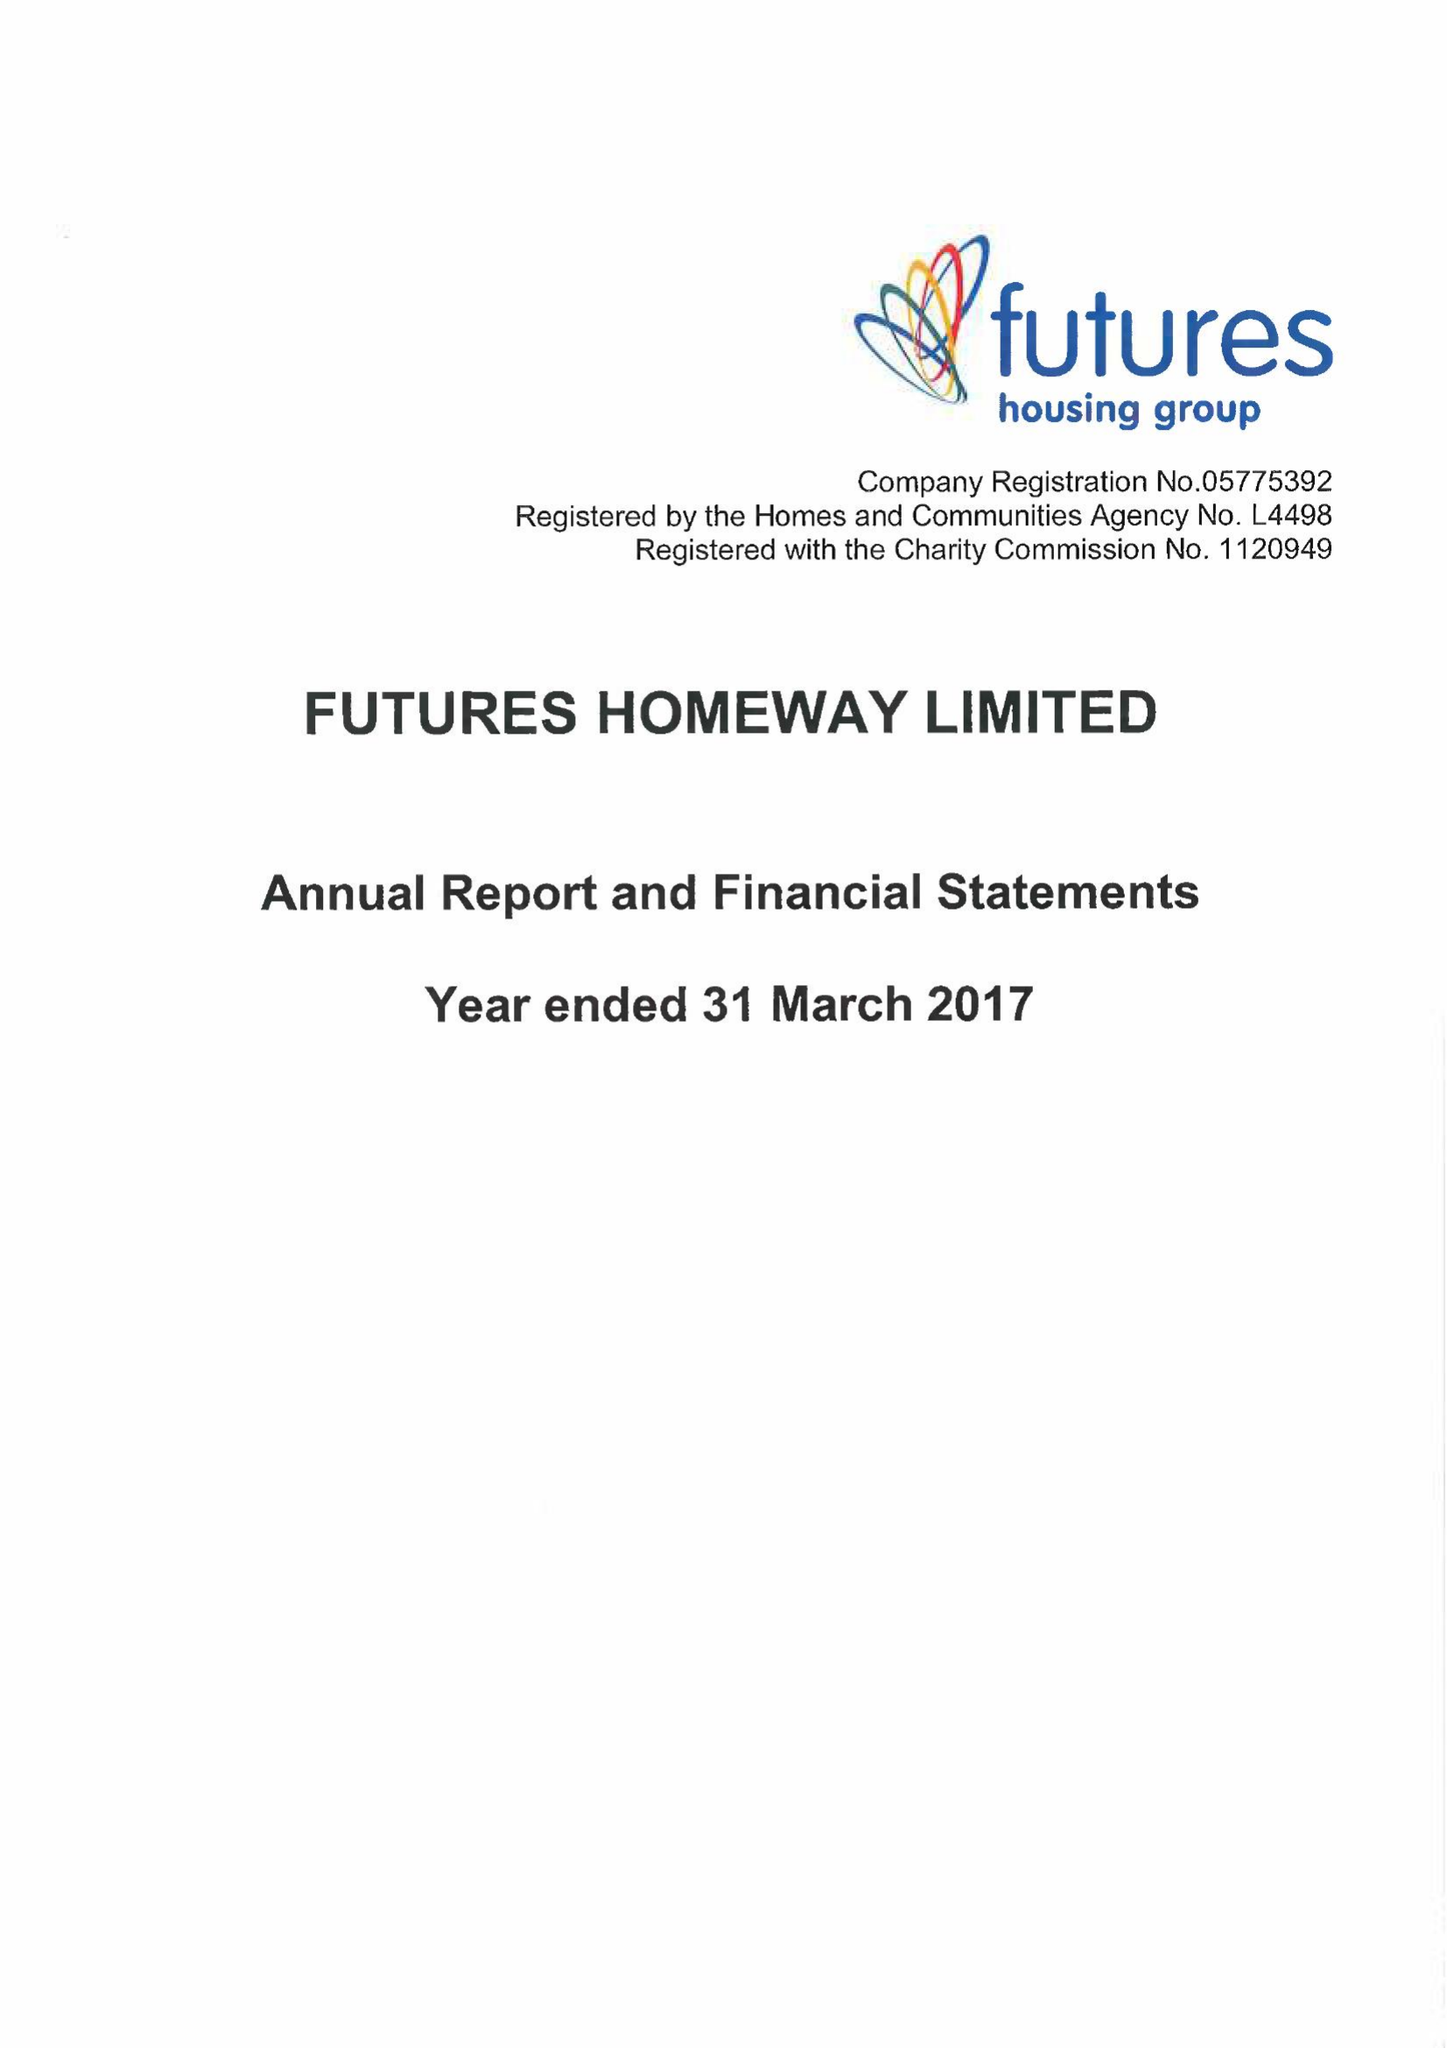What is the value for the report_date?
Answer the question using a single word or phrase. 2017-03-31 